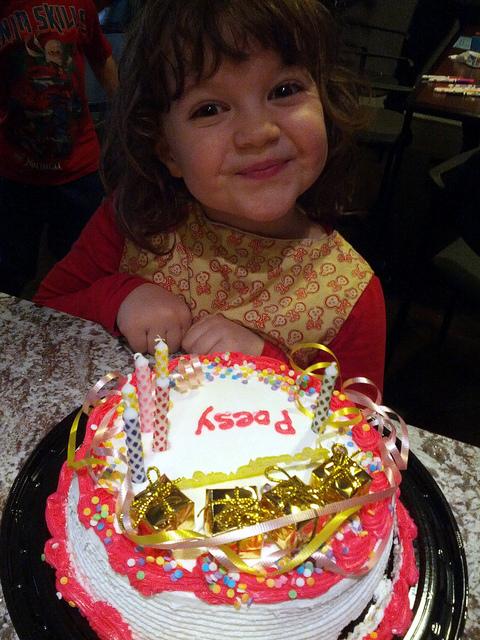What is the name on the cake?
Quick response, please. Poesy. How many candles on the cake?
Quick response, please. 6. What colors are the tablecloth?
Answer briefly. White and brown. What type of event is this cake for?
Write a very short answer. Birthday. 